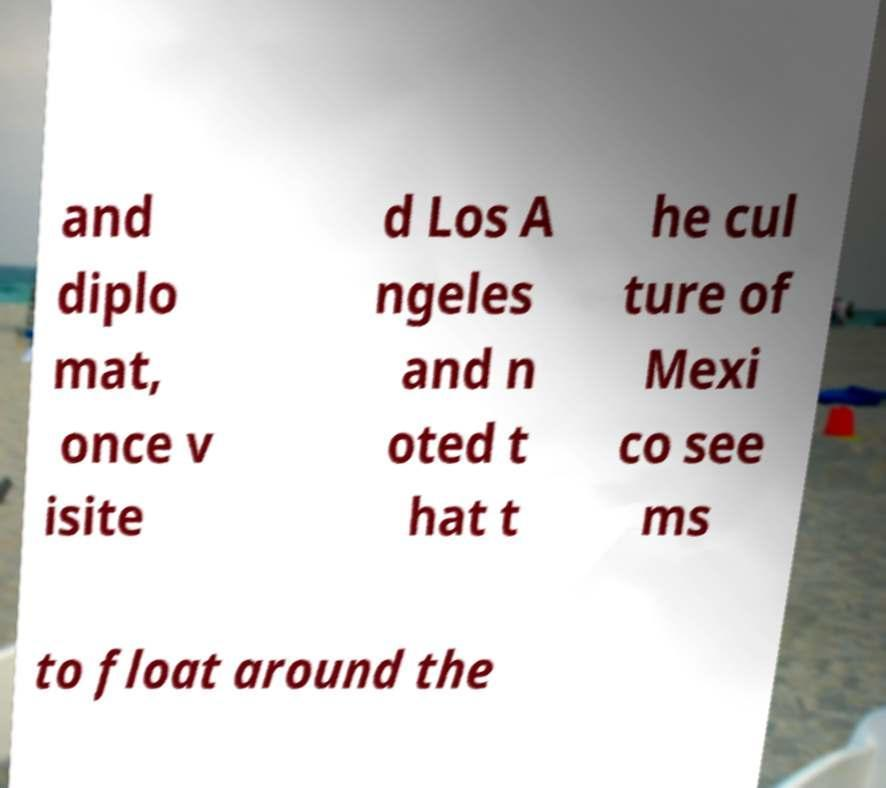I need the written content from this picture converted into text. Can you do that? and diplo mat, once v isite d Los A ngeles and n oted t hat t he cul ture of Mexi co see ms to float around the 